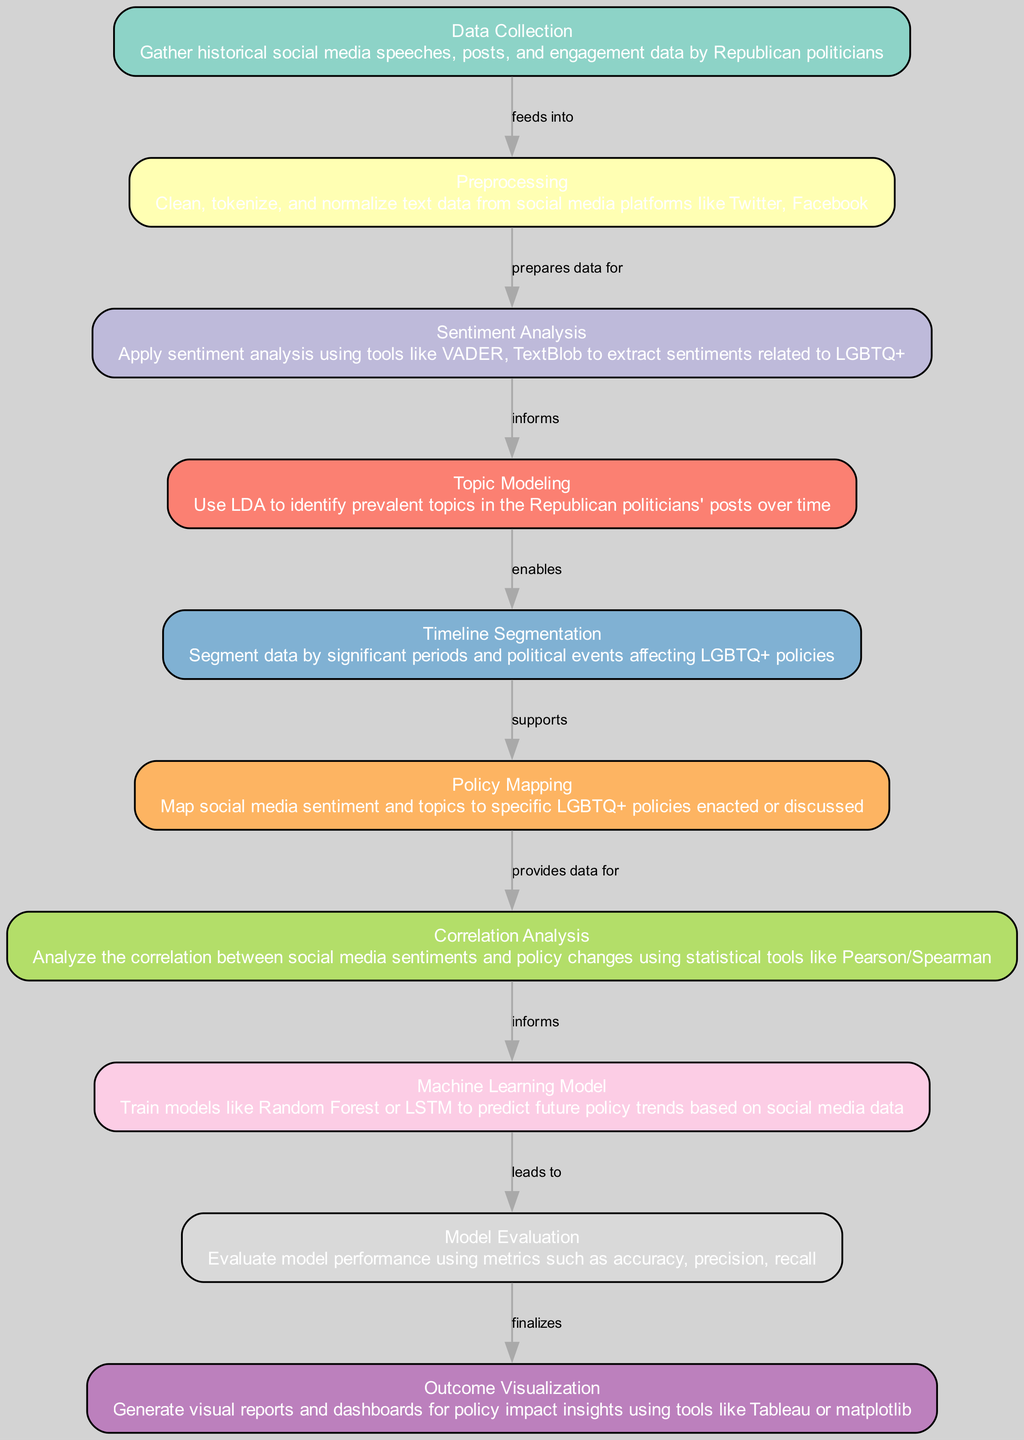What is the first node in the diagram? The first node in the diagram is identified as "Data Collection," which is where the process begins.
Answer: Data Collection How many nodes are present in the diagram? The diagram has a total of 10 nodes that represent various stages in the machine learning process.
Answer: 10 What is the label of the node that analyzes correlation? The label for the node that analyzes correlation is "Correlation Analysis." This node specifically examines the relationship between social media sentiments and policy changes.
Answer: Correlation Analysis Which node leads to model evaluation? The node that leads to "Model Evaluation" is "Machine Learning Model," where models are trained to predict future policy trends.
Answer: Machine Learning Model What type of analysis is performed after sentiment analysis? After "Sentiment Analysis," "Topic Modeling" is performed to identify and categorize the prevalent topics within the analyzed sentiments.
Answer: Topic Modeling Describe the relationship between preprocessing and sentiment analysis. "Preprocessing" prepares the cleaned and normalized data from social media, which is then used for "Sentiment Analysis" to extract relevant sentiments related to LGBTQ+.
Answer: Prepares data for What is the last node in the diagram? The last node in the diagram is "Outcome Visualization," which finalizes the process by generating visual reports and dashboards for insights.
Answer: Outcome Visualization How do significant political events affect timeline segmentation? Significant political events play a crucial role in "Timeline Segmentation" as they help segment the data into relevant periods to analyze the impact of those events on LGBTQ+ policies.
Answer: Supports Which statistical tools are mentioned for correlation analysis? The statistical tools mentioned for analyzing correlation are Pearson and Spearman, used to examine the relationship between sentiments and policy changes.
Answer: Pearson/Spearman 